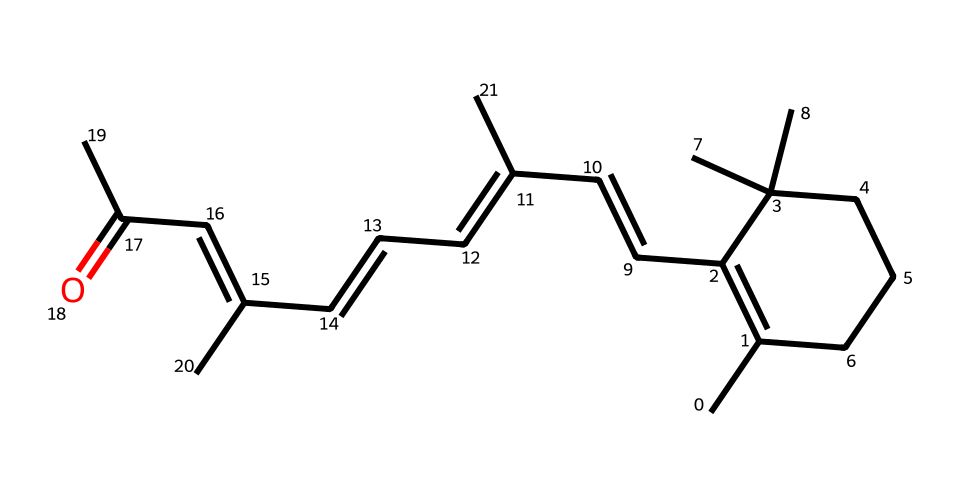What is the systematic name of this vitamin? The SMILES represents the chemical structure of vitamin A, which is commonly known as retinol. This name is derived from its chemical properties and usage in biological systems.
Answer: retinol How many carbon atoms are in this structure? By counting the carbons indicated in the SMILES notation, we find that there are 20 carbon atoms present in the structure of vitamin A.
Answer: 20 What type of functional group is present in the structure? The SMILES indicates the presence of a carbonyl group (C=O), which is characteristic of aldehydes and ketones. In retinol, this group is responsible for its activity as a vitamin.
Answer: carbonyl How many double bonds are present in this molecule? Analyzing the structure reveals that there are 5 double bonds within the carbon chain, contributing to the unsaturation of the molecule.
Answer: 5 What is the main role of vitamin A in the body? Vitamin A, or retinol, is primarily involved in vision, particularly in the formation of rhodopsin in the retina, which is essential for low-light vision.
Answer: vision What type of vitamin is vitamin A classified as? Vitamin A is classified as a fat-soluble vitamin, which means it is soluble in fats and oils, allowing for its storage in body tissues.
Answer: fat-soluble 